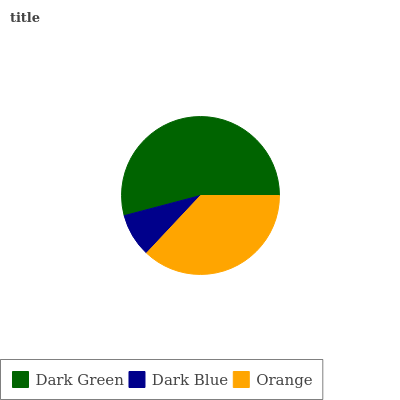Is Dark Blue the minimum?
Answer yes or no. Yes. Is Dark Green the maximum?
Answer yes or no. Yes. Is Orange the minimum?
Answer yes or no. No. Is Orange the maximum?
Answer yes or no. No. Is Orange greater than Dark Blue?
Answer yes or no. Yes. Is Dark Blue less than Orange?
Answer yes or no. Yes. Is Dark Blue greater than Orange?
Answer yes or no. No. Is Orange less than Dark Blue?
Answer yes or no. No. Is Orange the high median?
Answer yes or no. Yes. Is Orange the low median?
Answer yes or no. Yes. Is Dark Green the high median?
Answer yes or no. No. Is Dark Green the low median?
Answer yes or no. No. 